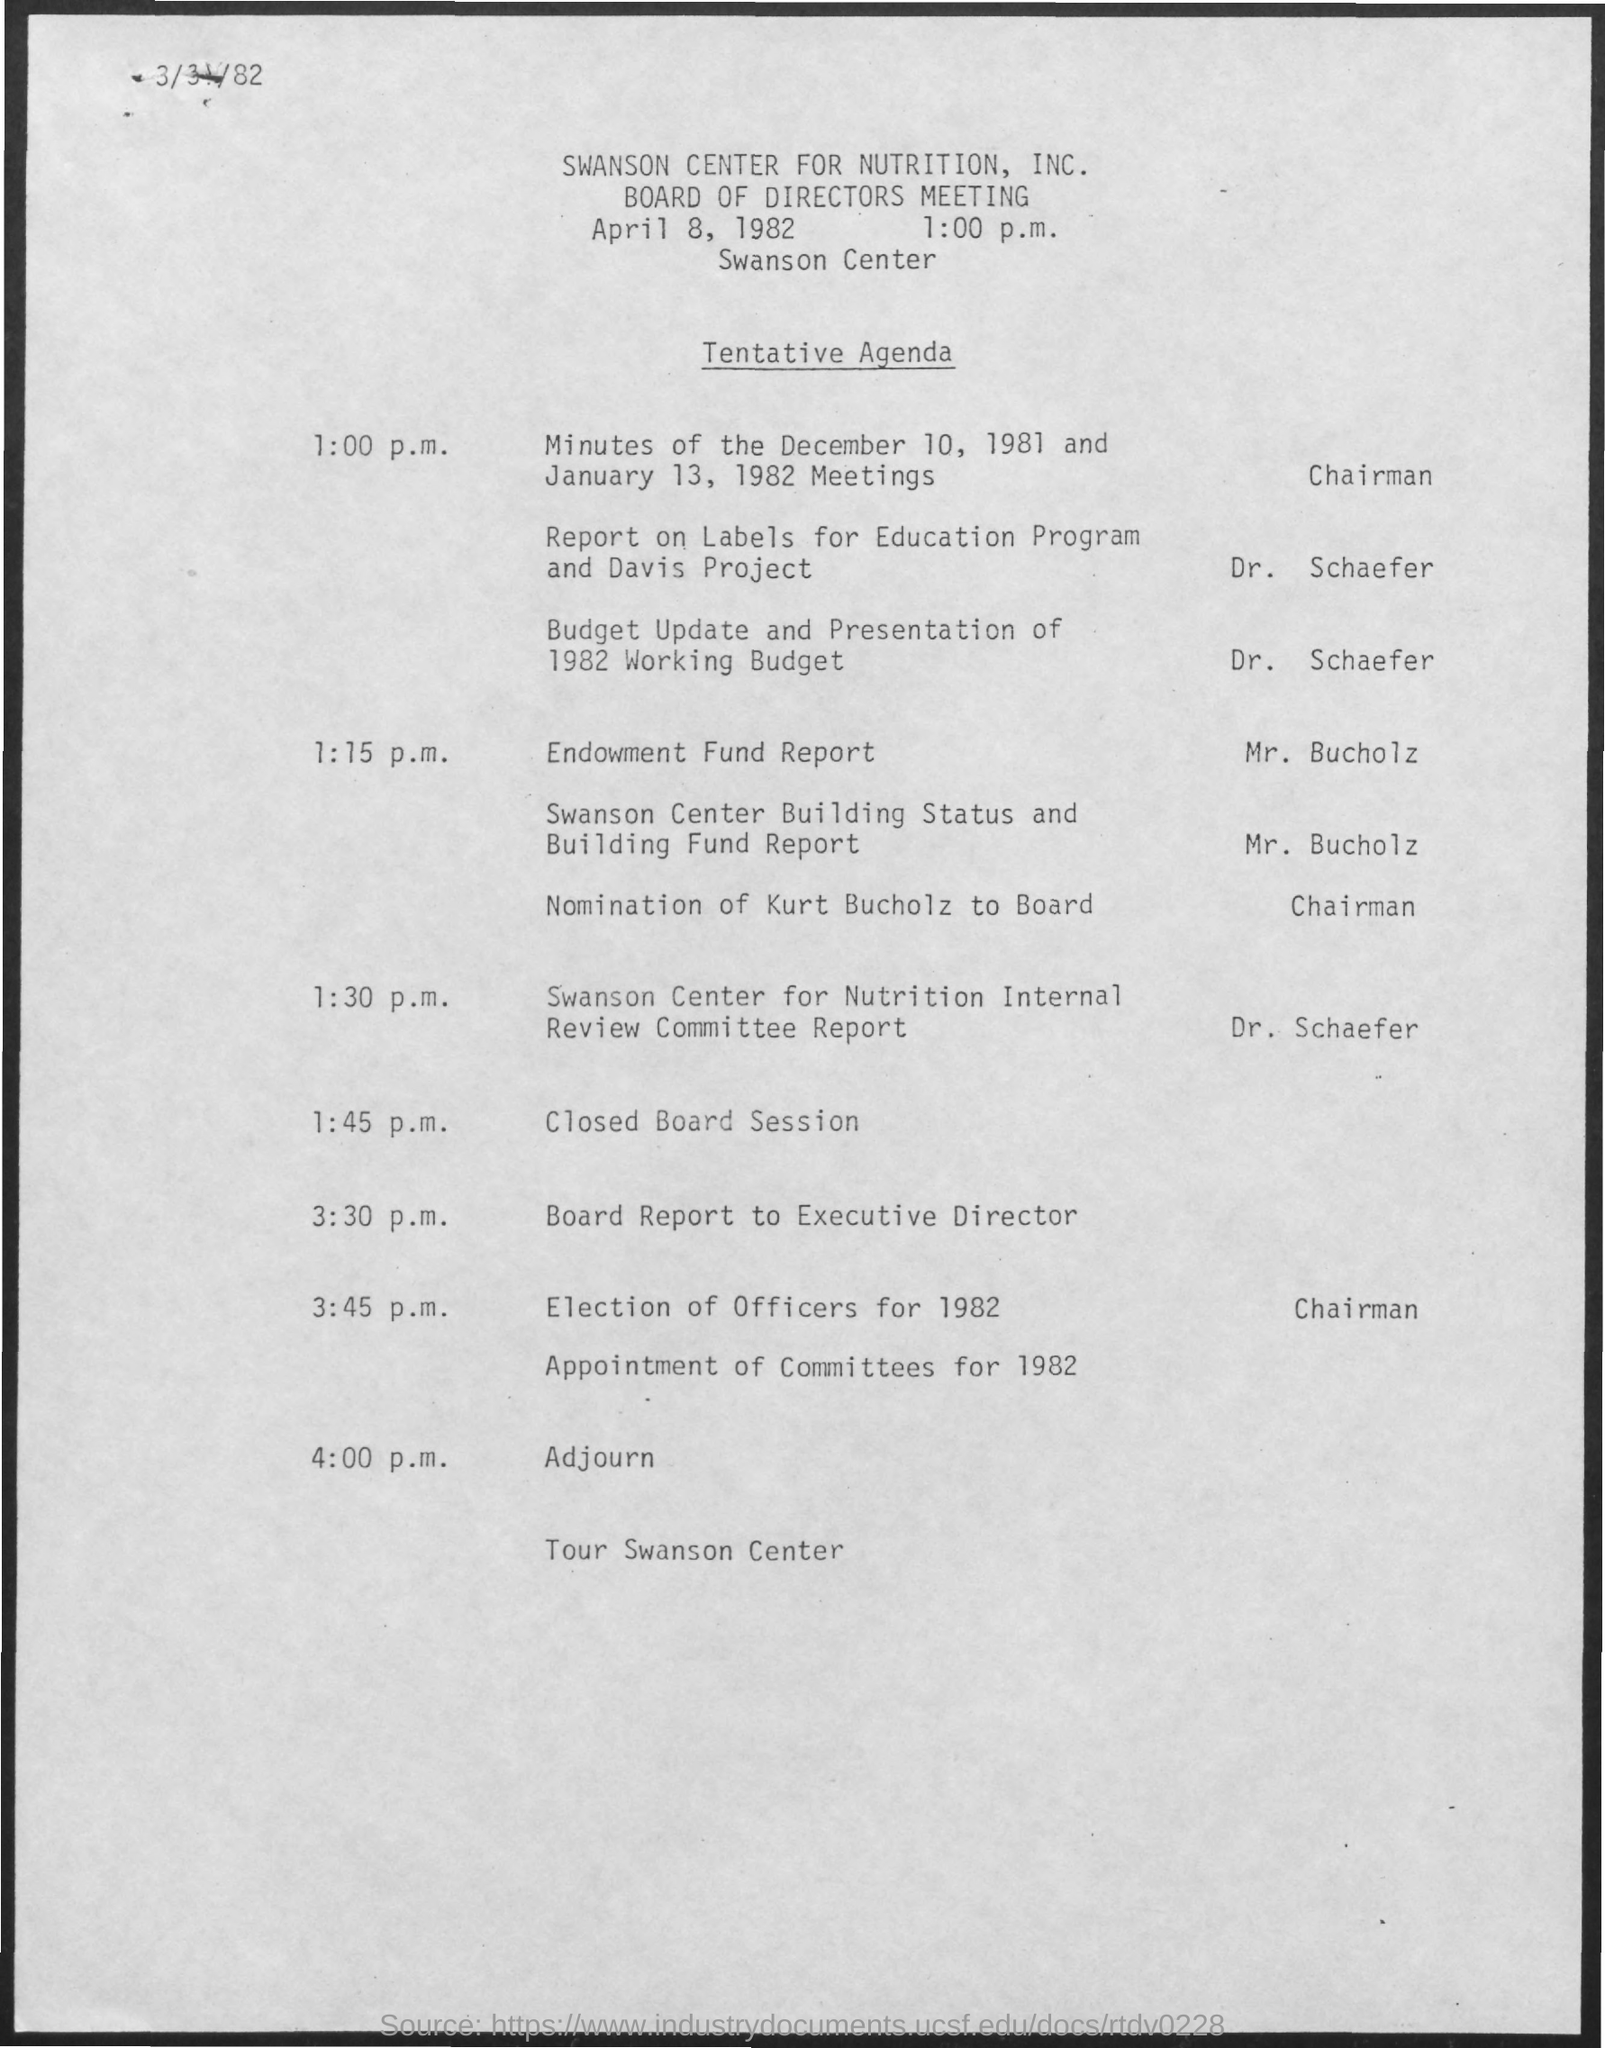When is the board of director's meeting?
Provide a succinct answer. April 8, 1982 1:00 p.m. Where is the meeting?
Your response must be concise. SWANSON CENTER FOR NUTRITION, INC. Who will present the Endowment Fund Report?
Give a very brief answer. Mr. Bucholz. At what time is the Election of Officers for 1982?
Your answer should be compact. 3:45 p.m. 